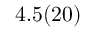Convert formula to latex. <formula><loc_0><loc_0><loc_500><loc_500>4 . 5 ( 2 0 )</formula> 